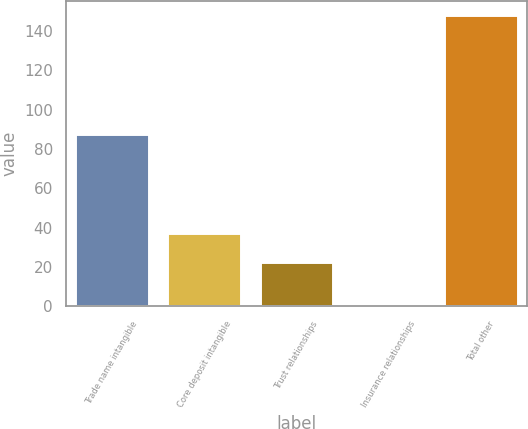<chart> <loc_0><loc_0><loc_500><loc_500><bar_chart><fcel>Trade name intangible<fcel>Core deposit intangible<fcel>Trust relationships<fcel>Insurance relationships<fcel>Total other<nl><fcel>87.8<fcel>37.4<fcel>22.7<fcel>1<fcel>148<nl></chart> 